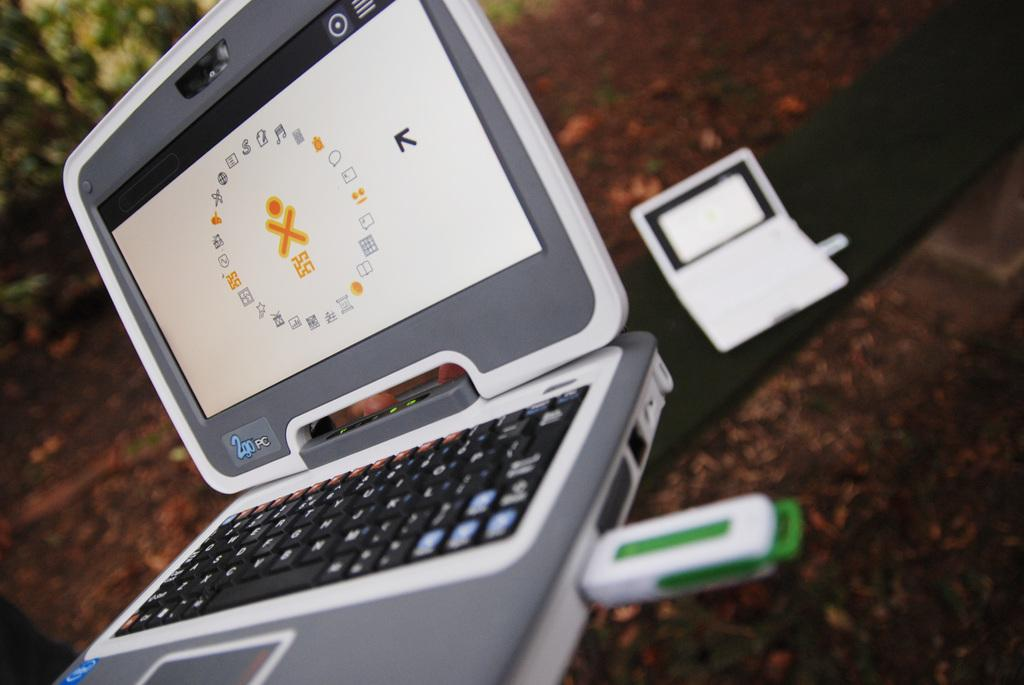Provide a one-sentence caption for the provided image. A series of symbols are displayed on a 2go Pc. 